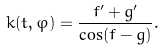<formula> <loc_0><loc_0><loc_500><loc_500>k ( t , \varphi ) = \frac { f ^ { \prime } + g ^ { \prime } } { \cos ( f - g ) } .</formula> 